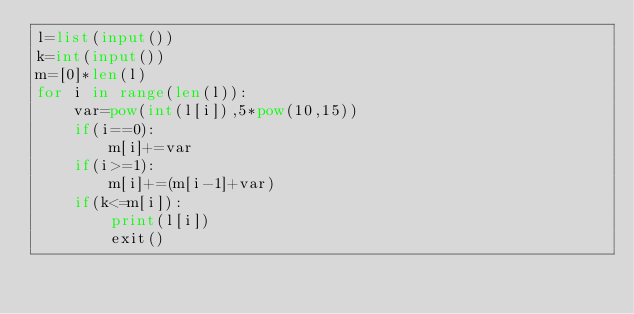<code> <loc_0><loc_0><loc_500><loc_500><_Python_>l=list(input())
k=int(input())
m=[0]*len(l)
for i in range(len(l)):
    var=pow(int(l[i]),5*pow(10,15))
    if(i==0):
        m[i]+=var
    if(i>=1):
        m[i]+=(m[i-1]+var)
    if(k<=m[i]):
        print(l[i])
        exit()</code> 